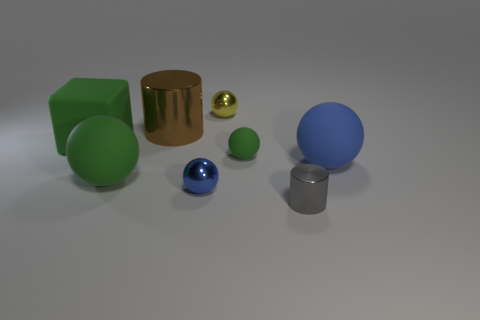What number of spheres are either small shiny objects or tiny yellow objects?
Keep it short and to the point. 2. Does the yellow thing have the same size as the blue ball that is left of the yellow metal ball?
Provide a succinct answer. Yes. Is the number of tiny things to the right of the tiny blue metallic ball greater than the number of blocks?
Offer a very short reply. Yes. The cylinder that is the same material as the gray object is what size?
Ensure brevity in your answer.  Large. Is there a object of the same color as the small matte ball?
Keep it short and to the point. Yes. What number of objects are either green cubes or shiny things that are on the left side of the small gray shiny object?
Keep it short and to the point. 4. Is the number of small blue things greater than the number of big gray matte objects?
Give a very brief answer. Yes. There is another matte sphere that is the same color as the tiny rubber sphere; what is its size?
Make the answer very short. Large. Are there any tiny yellow spheres made of the same material as the yellow thing?
Give a very brief answer. No. There is a tiny thing that is both in front of the tiny green object and on the right side of the yellow metallic object; what is its shape?
Your response must be concise. Cylinder. 